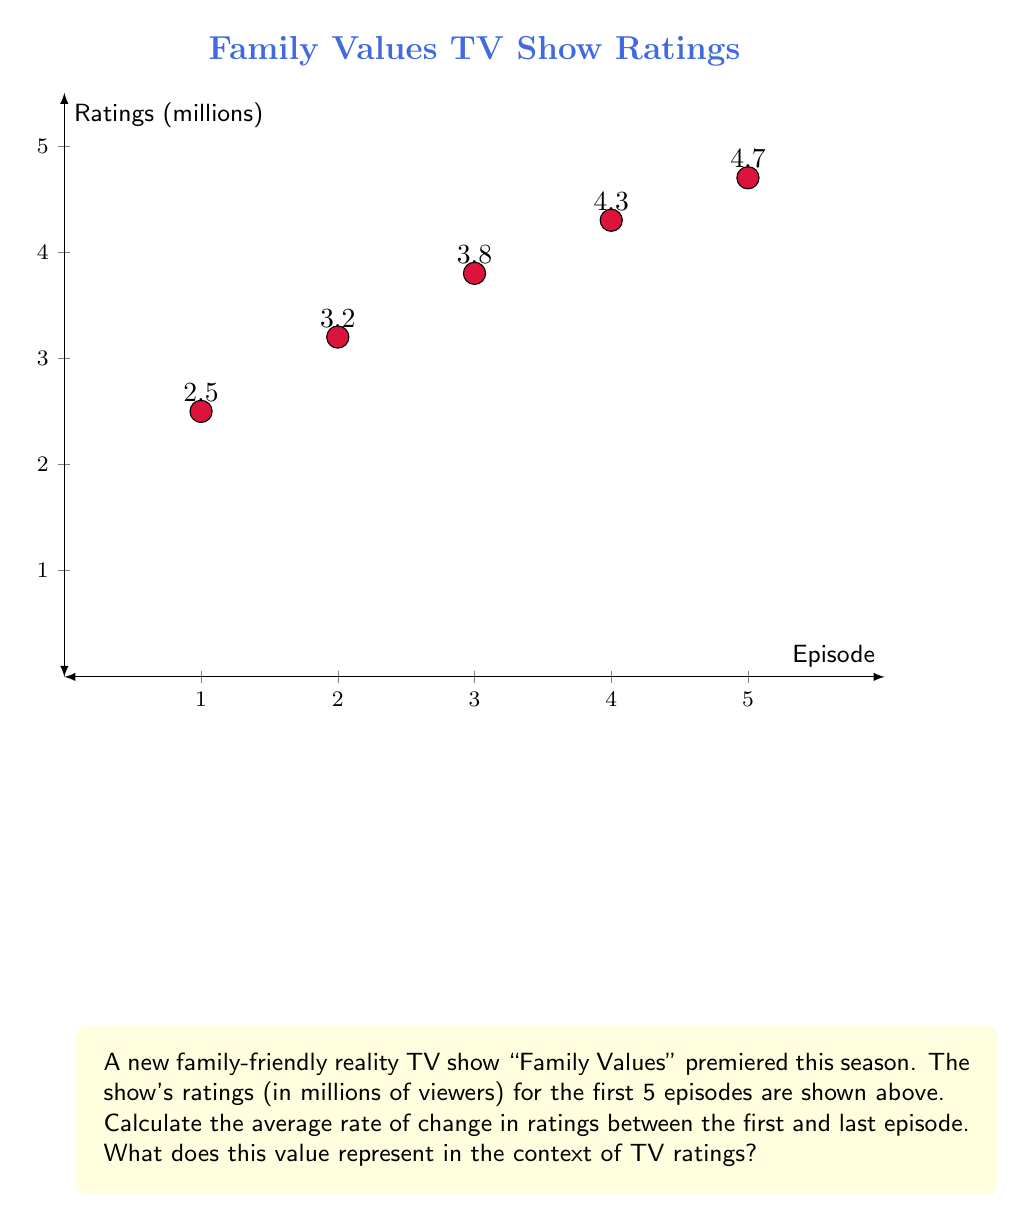Can you answer this question? To solve this problem, we'll use the average rate of change formula:

$$ \text{Average rate of change} = \frac{\text{Change in y}}{\text{Change in x}} = \frac{y_2 - y_1}{x_2 - x_1} $$

Where:
- $y_2$ is the final rating (episode 5)
- $y_1$ is the initial rating (episode 1)
- $x_2$ is the final episode number (5)
- $x_1$ is the initial episode number (1)

Step 1: Identify the values
$y_2 = 4.7$ million viewers (episode 5)
$y_1 = 2.5$ million viewers (episode 1)
$x_2 = 5$ (episode 5)
$x_1 = 1$ (episode 1)

Step 2: Apply the formula
$$ \text{Average rate of change} = \frac{4.7 - 2.5}{5 - 1} = \frac{2.2}{4} = 0.55 $$

Step 3: Interpret the result
The average rate of change is 0.55 million viewers per episode. This means that, on average, the show gained 0.55 million viewers with each new episode.

This value represents the steady growth in popularity of the show "Family Values" over its first five episodes. It indicates a positive trend in viewership, which is crucial for a new TV show's success and potential renewal.
Answer: 0.55 million viewers per episode 